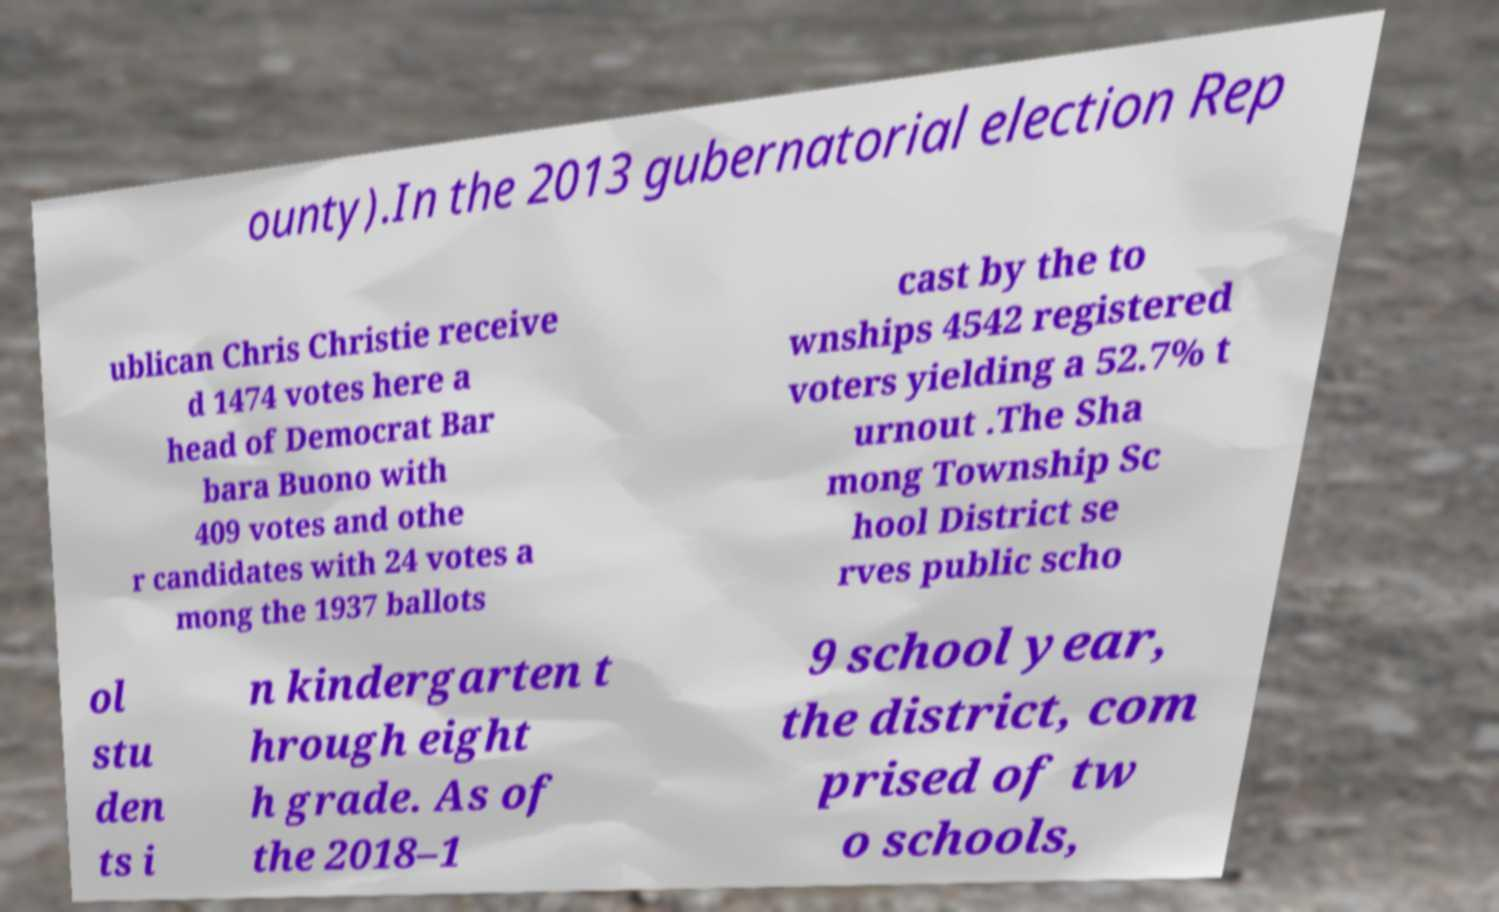Could you extract and type out the text from this image? ounty).In the 2013 gubernatorial election Rep ublican Chris Christie receive d 1474 votes here a head of Democrat Bar bara Buono with 409 votes and othe r candidates with 24 votes a mong the 1937 ballots cast by the to wnships 4542 registered voters yielding a 52.7% t urnout .The Sha mong Township Sc hool District se rves public scho ol stu den ts i n kindergarten t hrough eight h grade. As of the 2018–1 9 school year, the district, com prised of tw o schools, 